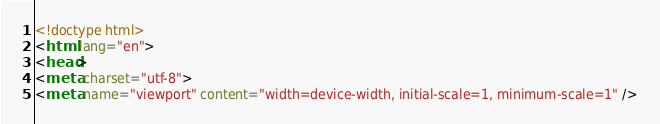<code> <loc_0><loc_0><loc_500><loc_500><_HTML_><!doctype html>
<html lang="en">
<head>
<meta charset="utf-8">
<meta name="viewport" content="width=device-width, initial-scale=1, minimum-scale=1" /></code> 